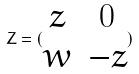<formula> <loc_0><loc_0><loc_500><loc_500>Z = ( \begin{matrix} z & 0 \\ w & - z \end{matrix} )</formula> 